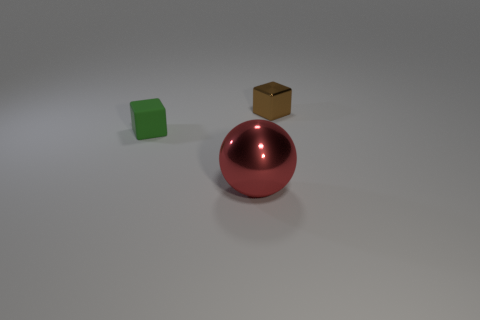What could be the purpose of these objects being placed together? These objects, looking like common geometric shapes, might be used for educational purposes to teach about shapes, dimensions, and materials, or they could be elements in a minimalist art composition highlighting form and color contrasts. 